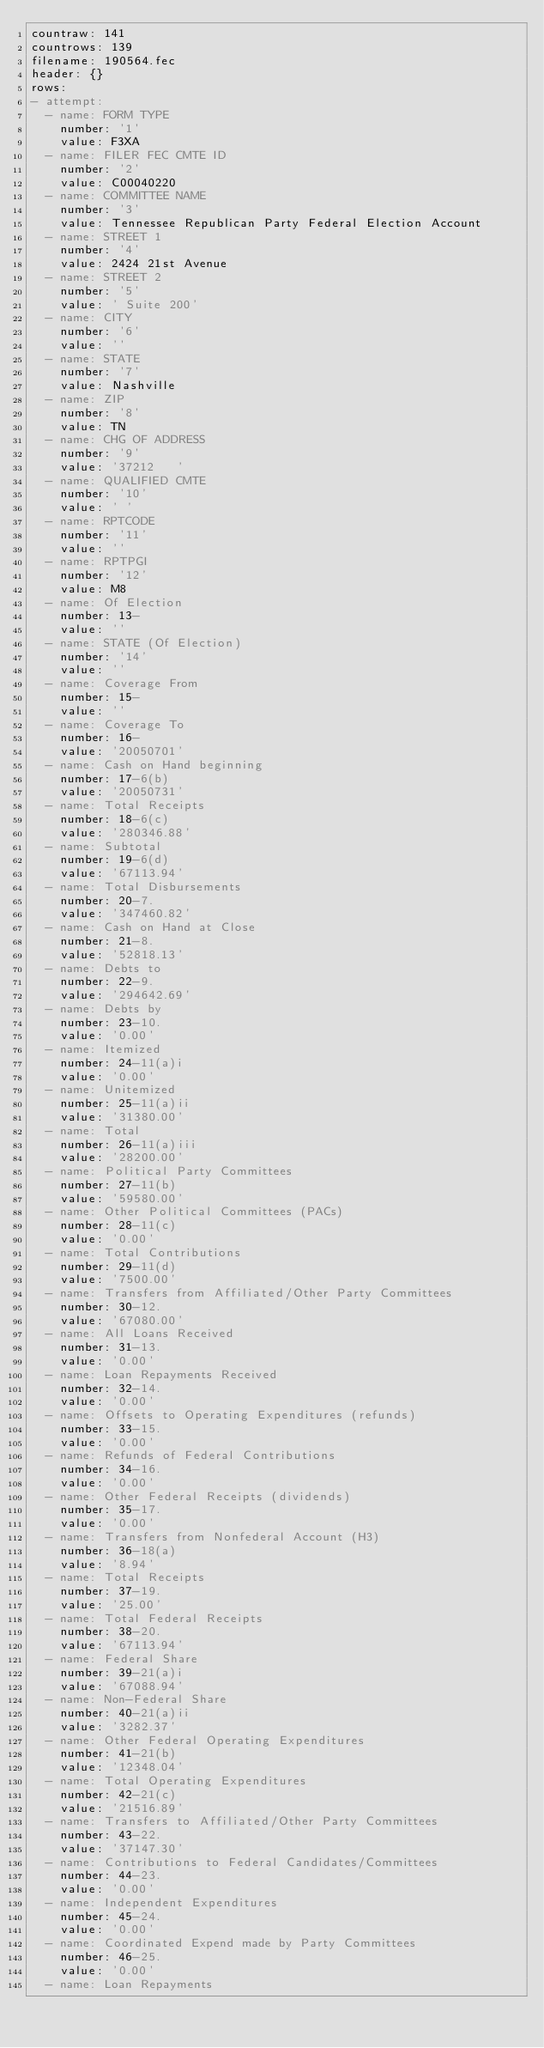<code> <loc_0><loc_0><loc_500><loc_500><_YAML_>countraw: 141
countrows: 139
filename: 190564.fec
header: {}
rows:
- attempt:
  - name: FORM TYPE
    number: '1'
    value: F3XA
  - name: FILER FEC CMTE ID
    number: '2'
    value: C00040220
  - name: COMMITTEE NAME
    number: '3'
    value: Tennessee Republican Party Federal Election Account
  - name: STREET 1
    number: '4'
    value: 2424 21st Avenue
  - name: STREET 2
    number: '5'
    value: ' Suite 200'
  - name: CITY
    number: '6'
    value: ''
  - name: STATE
    number: '7'
    value: Nashville
  - name: ZIP
    number: '8'
    value: TN
  - name: CHG OF ADDRESS
    number: '9'
    value: '37212   '
  - name: QUALIFIED CMTE
    number: '10'
    value: ' '
  - name: RPTCODE
    number: '11'
    value: ''
  - name: RPTPGI
    number: '12'
    value: M8
  - name: Of Election
    number: 13-
    value: ''
  - name: STATE (Of Election)
    number: '14'
    value: ''
  - name: Coverage From
    number: 15-
    value: ''
  - name: Coverage To
    number: 16-
    value: '20050701'
  - name: Cash on Hand beginning
    number: 17-6(b)
    value: '20050731'
  - name: Total Receipts
    number: 18-6(c)
    value: '280346.88'
  - name: Subtotal
    number: 19-6(d)
    value: '67113.94'
  - name: Total Disbursements
    number: 20-7.
    value: '347460.82'
  - name: Cash on Hand at Close
    number: 21-8.
    value: '52818.13'
  - name: Debts to
    number: 22-9.
    value: '294642.69'
  - name: Debts by
    number: 23-10.
    value: '0.00'
  - name: Itemized
    number: 24-11(a)i
    value: '0.00'
  - name: Unitemized
    number: 25-11(a)ii
    value: '31380.00'
  - name: Total
    number: 26-11(a)iii
    value: '28200.00'
  - name: Political Party Committees
    number: 27-11(b)
    value: '59580.00'
  - name: Other Political Committees (PACs)
    number: 28-11(c)
    value: '0.00'
  - name: Total Contributions
    number: 29-11(d)
    value: '7500.00'
  - name: Transfers from Affiliated/Other Party Committees
    number: 30-12.
    value: '67080.00'
  - name: All Loans Received
    number: 31-13.
    value: '0.00'
  - name: Loan Repayments Received
    number: 32-14.
    value: '0.00'
  - name: Offsets to Operating Expenditures (refunds)
    number: 33-15.
    value: '0.00'
  - name: Refunds of Federal Contributions
    number: 34-16.
    value: '0.00'
  - name: Other Federal Receipts (dividends)
    number: 35-17.
    value: '0.00'
  - name: Transfers from Nonfederal Account (H3)
    number: 36-18(a)
    value: '8.94'
  - name: Total Receipts
    number: 37-19.
    value: '25.00'
  - name: Total Federal Receipts
    number: 38-20.
    value: '67113.94'
  - name: Federal Share
    number: 39-21(a)i
    value: '67088.94'
  - name: Non-Federal Share
    number: 40-21(a)ii
    value: '3282.37'
  - name: Other Federal Operating Expenditures
    number: 41-21(b)
    value: '12348.04'
  - name: Total Operating Expenditures
    number: 42-21(c)
    value: '21516.89'
  - name: Transfers to Affiliated/Other Party Committees
    number: 43-22.
    value: '37147.30'
  - name: Contributions to Federal Candidates/Committees
    number: 44-23.
    value: '0.00'
  - name: Independent Expenditures
    number: 45-24.
    value: '0.00'
  - name: Coordinated Expend made by Party Committees
    number: 46-25.
    value: '0.00'
  - name: Loan Repayments</code> 